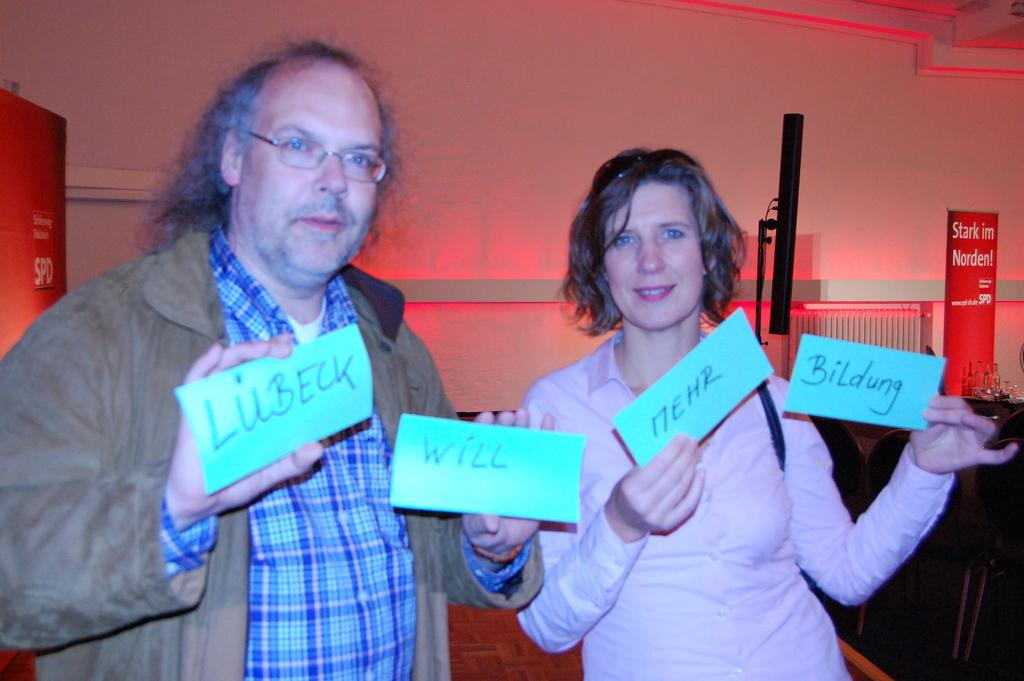What are the people in the image doing? The people in the image are standing and holding paper slips in their hands. What else can be seen in the image besides the people? There is a water jar visible in the image, and glasses are present on a table. What type of plane can be seen flying in the image? There is no plane visible in the image. What is the people's breakfast in the image? There is no mention of breakfast in the image. 